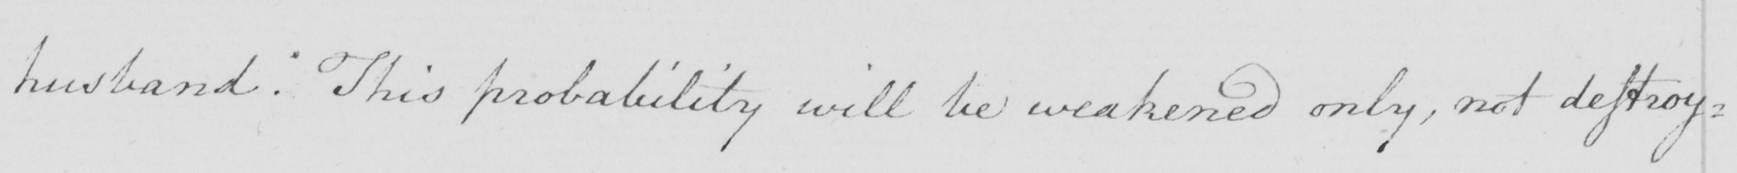Transcribe the text shown in this historical manuscript line. husband . This probability will be weakened only , not destroy= 